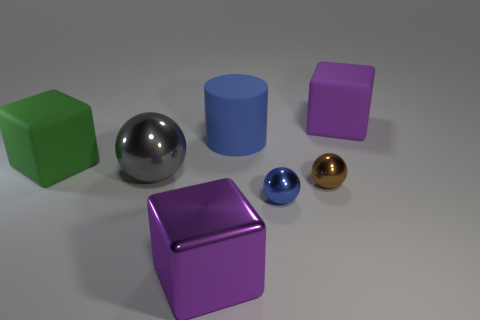Subtract all tiny brown shiny balls. How many balls are left? 2 Add 2 gray balls. How many objects exist? 9 Subtract all blue balls. How many balls are left? 2 Subtract all blocks. How many objects are left? 4 Subtract 1 cylinders. How many cylinders are left? 0 Subtract all blue cubes. How many brown balls are left? 1 Subtract all cyan cylinders. Subtract all yellow blocks. How many cylinders are left? 1 Subtract all large purple matte blocks. Subtract all cylinders. How many objects are left? 5 Add 5 large objects. How many large objects are left? 10 Add 1 green objects. How many green objects exist? 2 